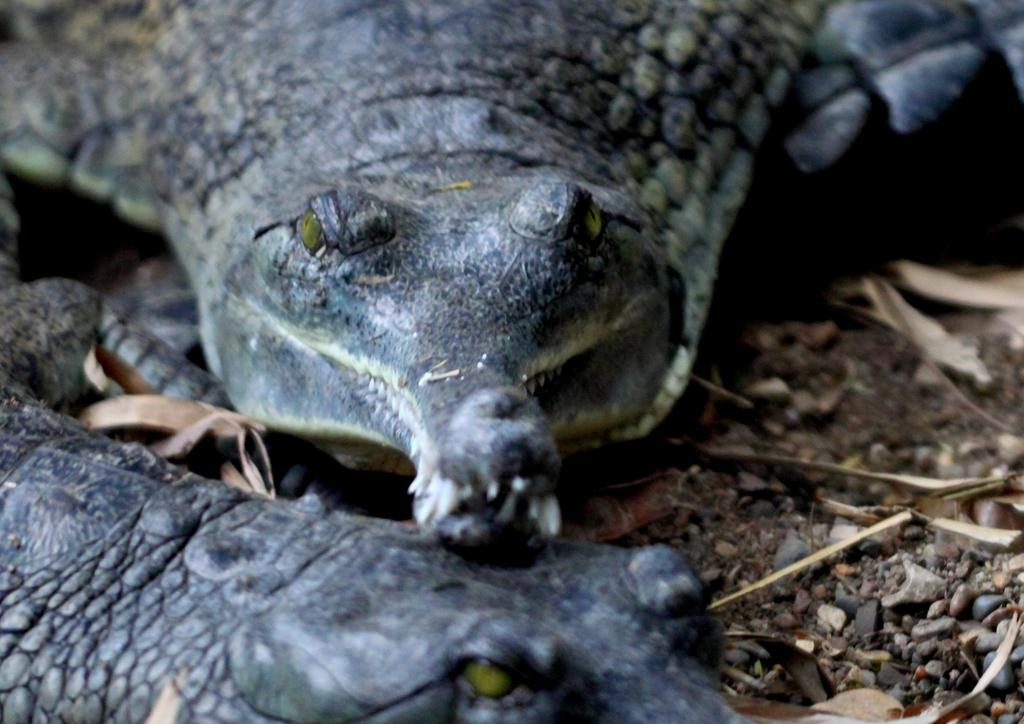How many crocodiles are in the image? There are two crocodiles in the image. Where are the crocodiles located in the image? The crocodiles are on the ground in the image. What color are the crocodiles? The crocodiles are grey in color. What can be seen on the ground in the image besides the crocodiles? There are small stones on the ground in the image. How many toes does the crocodile have on its left front foot in the image? The image does not provide enough detail to count the toes on the crocodile's feet. 